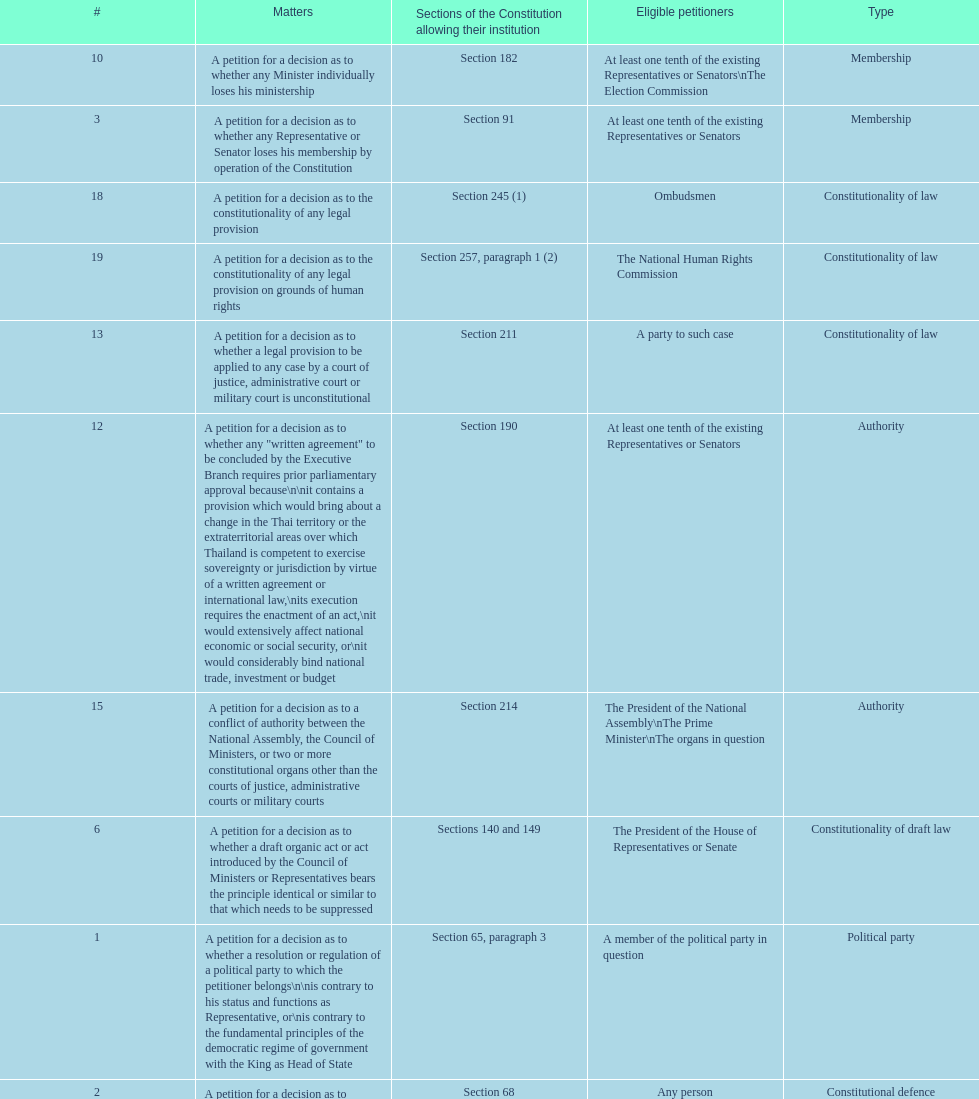Any person can petition matters 2 and 17. true or false? True. 